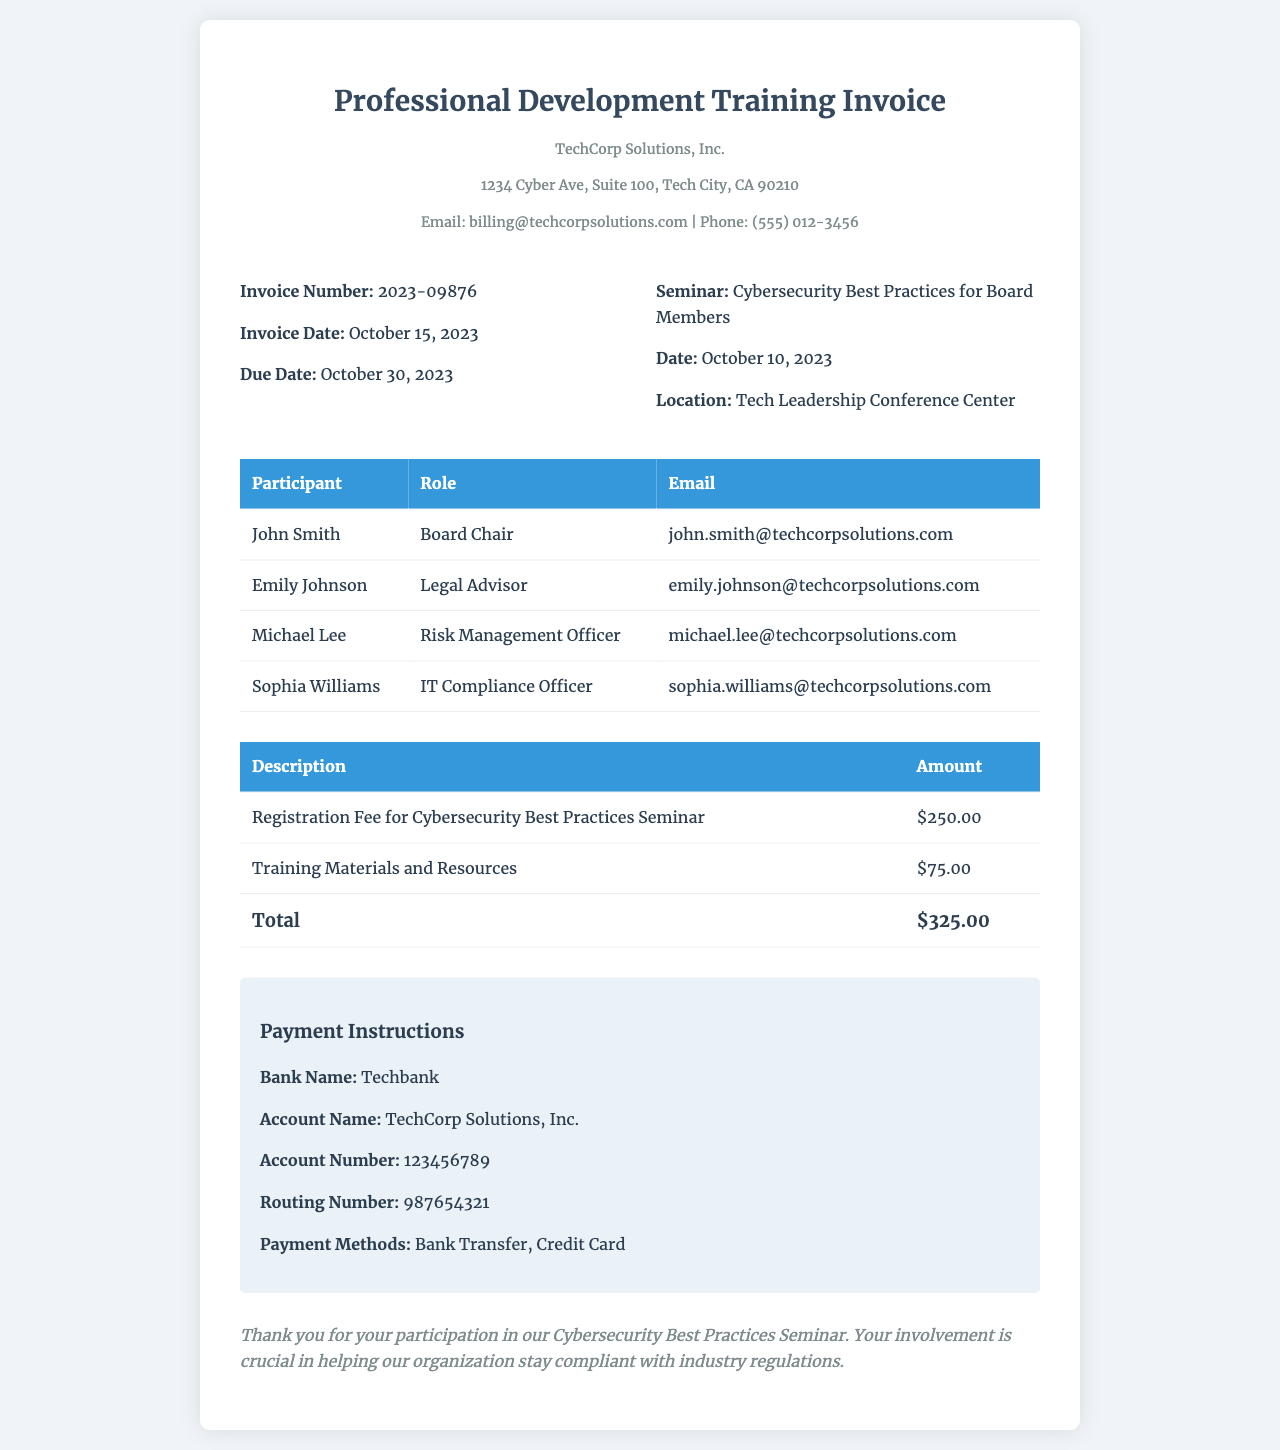What is the invoice number? The invoice number can be found in the invoice info section of the document.
Answer: 2023-09876 What is the total amount due? The total amount is presented in the second table under the total row.
Answer: $325.00 Who is the Legal Advisor? The role of Legal Advisor is listed in the participants table.
Answer: Emily Johnson When did the seminar take place? The date of the seminar is specifically mentioned in the invoice info section.
Answer: October 10, 2023 What is the due date for payment? The due date for payment is also provided in the invoice info section.
Answer: October 30, 2023 What is the registration fee? The registration fee is detailed in the description column of the invoice.
Answer: $250.00 What are the payment methods accepted? The payment methods are outlined in the payment instructions section.
Answer: Bank Transfer, Credit Card What is the location of the seminar? The location can be found in the invoice info section under the location field.
Answer: Tech Leadership Conference Center What is the name of the organization issuing the invoice? The name of the organization is stated at the top of the document.
Answer: TechCorp Solutions, Inc 